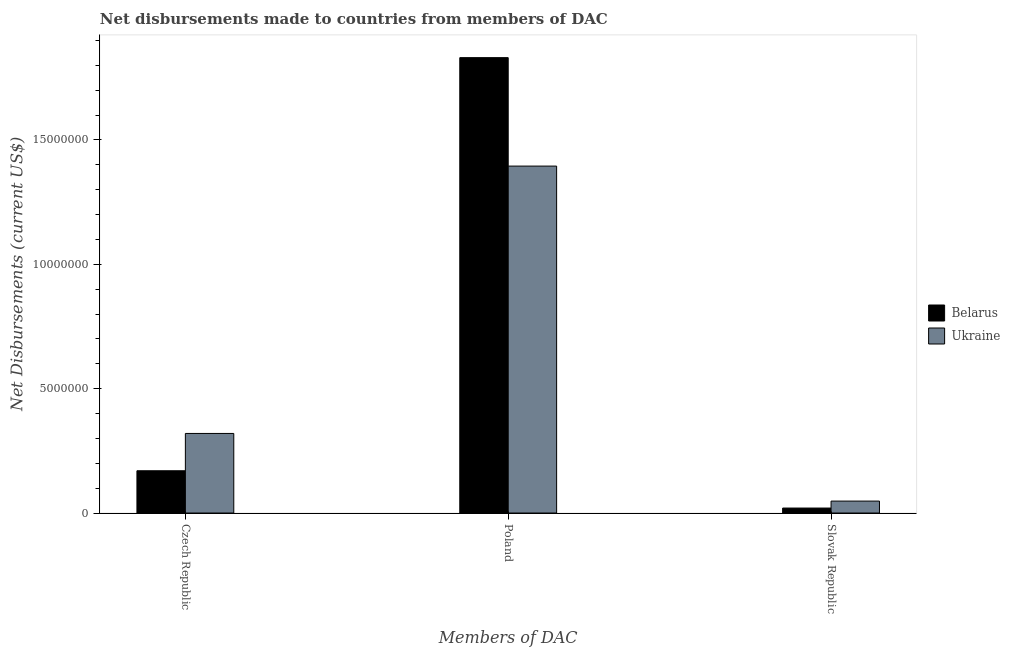How many groups of bars are there?
Provide a short and direct response. 3. Are the number of bars per tick equal to the number of legend labels?
Provide a short and direct response. Yes. Are the number of bars on each tick of the X-axis equal?
Provide a succinct answer. Yes. How many bars are there on the 3rd tick from the left?
Keep it short and to the point. 2. What is the label of the 1st group of bars from the left?
Provide a succinct answer. Czech Republic. What is the net disbursements made by czech republic in Belarus?
Offer a very short reply. 1.70e+06. Across all countries, what is the maximum net disbursements made by poland?
Provide a short and direct response. 1.83e+07. Across all countries, what is the minimum net disbursements made by slovak republic?
Provide a succinct answer. 2.00e+05. In which country was the net disbursements made by poland maximum?
Offer a very short reply. Belarus. In which country was the net disbursements made by czech republic minimum?
Ensure brevity in your answer.  Belarus. What is the total net disbursements made by slovak republic in the graph?
Provide a succinct answer. 6.80e+05. What is the difference between the net disbursements made by czech republic in Belarus and that in Ukraine?
Offer a very short reply. -1.50e+06. What is the difference between the net disbursements made by czech republic in Belarus and the net disbursements made by poland in Ukraine?
Give a very brief answer. -1.22e+07. What is the average net disbursements made by poland per country?
Your response must be concise. 1.61e+07. What is the difference between the net disbursements made by slovak republic and net disbursements made by poland in Belarus?
Your response must be concise. -1.81e+07. In how many countries, is the net disbursements made by poland greater than 15000000 US$?
Make the answer very short. 1. What is the ratio of the net disbursements made by poland in Ukraine to that in Belarus?
Your answer should be very brief. 0.76. Is the net disbursements made by slovak republic in Belarus less than that in Ukraine?
Offer a very short reply. Yes. What is the difference between the highest and the second highest net disbursements made by poland?
Make the answer very short. 4.36e+06. What is the difference between the highest and the lowest net disbursements made by poland?
Offer a terse response. 4.36e+06. In how many countries, is the net disbursements made by poland greater than the average net disbursements made by poland taken over all countries?
Your answer should be very brief. 1. What does the 1st bar from the left in Poland represents?
Your answer should be very brief. Belarus. What does the 1st bar from the right in Poland represents?
Your answer should be very brief. Ukraine. Are all the bars in the graph horizontal?
Give a very brief answer. No. How many countries are there in the graph?
Give a very brief answer. 2. What is the difference between two consecutive major ticks on the Y-axis?
Your answer should be very brief. 5.00e+06. Are the values on the major ticks of Y-axis written in scientific E-notation?
Offer a very short reply. No. Does the graph contain any zero values?
Provide a short and direct response. No. Where does the legend appear in the graph?
Offer a terse response. Center right. How are the legend labels stacked?
Keep it short and to the point. Vertical. What is the title of the graph?
Provide a succinct answer. Net disbursements made to countries from members of DAC. What is the label or title of the X-axis?
Keep it short and to the point. Members of DAC. What is the label or title of the Y-axis?
Offer a terse response. Net Disbursements (current US$). What is the Net Disbursements (current US$) in Belarus in Czech Republic?
Keep it short and to the point. 1.70e+06. What is the Net Disbursements (current US$) of Ukraine in Czech Republic?
Provide a short and direct response. 3.20e+06. What is the Net Disbursements (current US$) in Belarus in Poland?
Keep it short and to the point. 1.83e+07. What is the Net Disbursements (current US$) in Ukraine in Poland?
Give a very brief answer. 1.40e+07. What is the Net Disbursements (current US$) in Belarus in Slovak Republic?
Offer a very short reply. 2.00e+05. Across all Members of DAC, what is the maximum Net Disbursements (current US$) of Belarus?
Provide a short and direct response. 1.83e+07. Across all Members of DAC, what is the maximum Net Disbursements (current US$) of Ukraine?
Give a very brief answer. 1.40e+07. Across all Members of DAC, what is the minimum Net Disbursements (current US$) in Belarus?
Provide a short and direct response. 2.00e+05. What is the total Net Disbursements (current US$) of Belarus in the graph?
Provide a short and direct response. 2.02e+07. What is the total Net Disbursements (current US$) in Ukraine in the graph?
Offer a very short reply. 1.76e+07. What is the difference between the Net Disbursements (current US$) in Belarus in Czech Republic and that in Poland?
Offer a very short reply. -1.66e+07. What is the difference between the Net Disbursements (current US$) of Ukraine in Czech Republic and that in Poland?
Make the answer very short. -1.08e+07. What is the difference between the Net Disbursements (current US$) of Belarus in Czech Republic and that in Slovak Republic?
Ensure brevity in your answer.  1.50e+06. What is the difference between the Net Disbursements (current US$) of Ukraine in Czech Republic and that in Slovak Republic?
Give a very brief answer. 2.72e+06. What is the difference between the Net Disbursements (current US$) of Belarus in Poland and that in Slovak Republic?
Your answer should be very brief. 1.81e+07. What is the difference between the Net Disbursements (current US$) of Ukraine in Poland and that in Slovak Republic?
Offer a very short reply. 1.35e+07. What is the difference between the Net Disbursements (current US$) of Belarus in Czech Republic and the Net Disbursements (current US$) of Ukraine in Poland?
Provide a short and direct response. -1.22e+07. What is the difference between the Net Disbursements (current US$) in Belarus in Czech Republic and the Net Disbursements (current US$) in Ukraine in Slovak Republic?
Your response must be concise. 1.22e+06. What is the difference between the Net Disbursements (current US$) in Belarus in Poland and the Net Disbursements (current US$) in Ukraine in Slovak Republic?
Offer a very short reply. 1.78e+07. What is the average Net Disbursements (current US$) in Belarus per Members of DAC?
Provide a short and direct response. 6.74e+06. What is the average Net Disbursements (current US$) in Ukraine per Members of DAC?
Your response must be concise. 5.88e+06. What is the difference between the Net Disbursements (current US$) of Belarus and Net Disbursements (current US$) of Ukraine in Czech Republic?
Keep it short and to the point. -1.50e+06. What is the difference between the Net Disbursements (current US$) of Belarus and Net Disbursements (current US$) of Ukraine in Poland?
Offer a terse response. 4.36e+06. What is the difference between the Net Disbursements (current US$) in Belarus and Net Disbursements (current US$) in Ukraine in Slovak Republic?
Your answer should be compact. -2.80e+05. What is the ratio of the Net Disbursements (current US$) in Belarus in Czech Republic to that in Poland?
Ensure brevity in your answer.  0.09. What is the ratio of the Net Disbursements (current US$) in Ukraine in Czech Republic to that in Poland?
Provide a short and direct response. 0.23. What is the ratio of the Net Disbursements (current US$) of Belarus in Poland to that in Slovak Republic?
Your answer should be very brief. 91.55. What is the ratio of the Net Disbursements (current US$) in Ukraine in Poland to that in Slovak Republic?
Give a very brief answer. 29.06. What is the difference between the highest and the second highest Net Disbursements (current US$) in Belarus?
Make the answer very short. 1.66e+07. What is the difference between the highest and the second highest Net Disbursements (current US$) in Ukraine?
Provide a succinct answer. 1.08e+07. What is the difference between the highest and the lowest Net Disbursements (current US$) of Belarus?
Make the answer very short. 1.81e+07. What is the difference between the highest and the lowest Net Disbursements (current US$) in Ukraine?
Make the answer very short. 1.35e+07. 